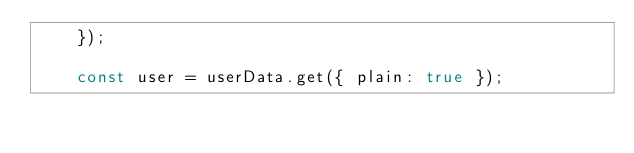Convert code to text. <code><loc_0><loc_0><loc_500><loc_500><_JavaScript_>    });

    const user = userData.get({ plain: true });
</code> 